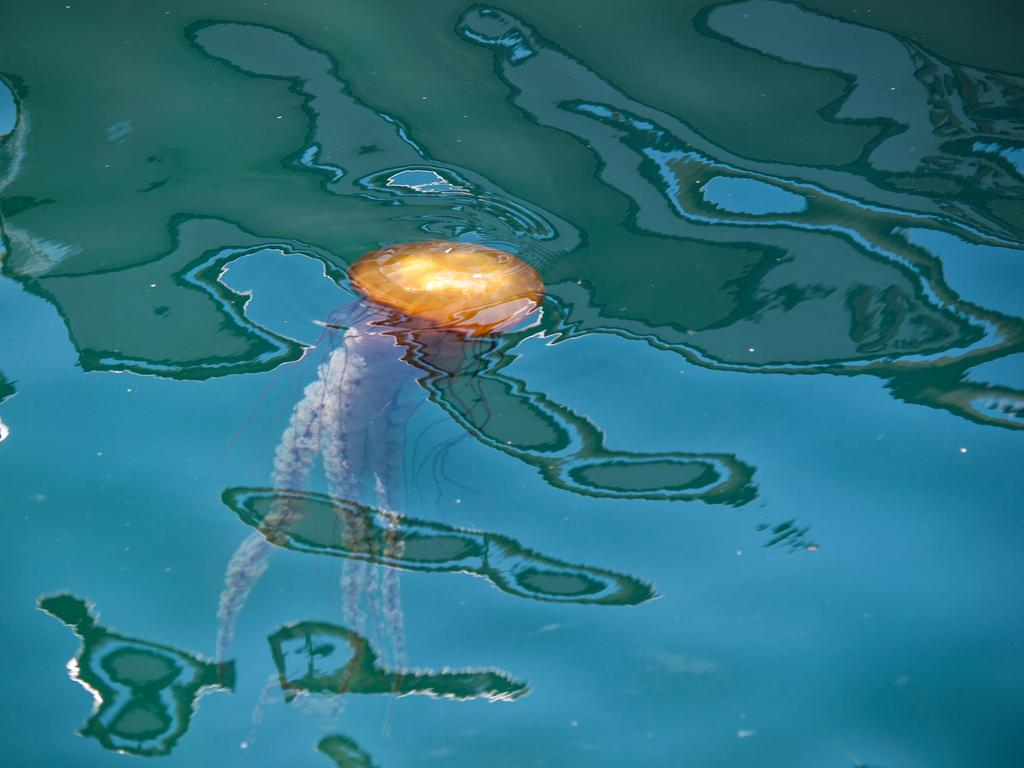What type of animal is in the image? There is a jellyfish in the image. Where is the jellyfish located? The jellyfish is in the water. What type of beginner's sack is visible in the image? There is no beginner's sack present in the image; it features a jellyfish in the water. 